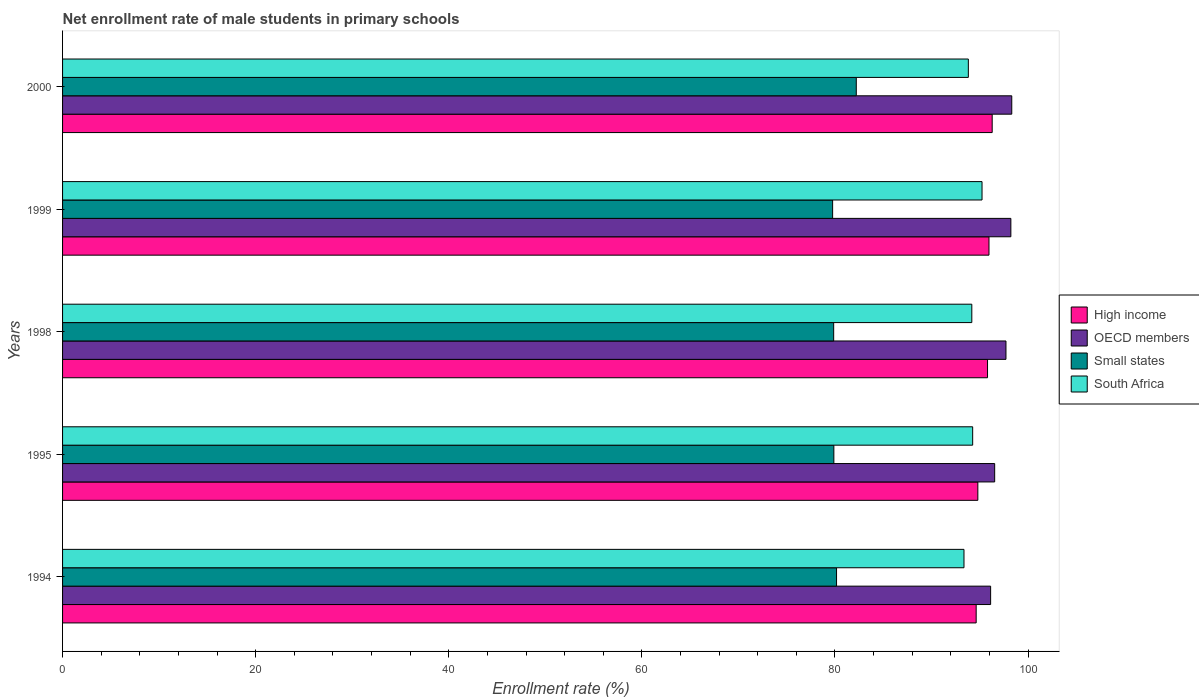How many different coloured bars are there?
Offer a very short reply. 4. How many groups of bars are there?
Your response must be concise. 5. Are the number of bars per tick equal to the number of legend labels?
Keep it short and to the point. Yes. What is the label of the 4th group of bars from the top?
Ensure brevity in your answer.  1995. In how many cases, is the number of bars for a given year not equal to the number of legend labels?
Offer a very short reply. 0. What is the net enrollment rate of male students in primary schools in Small states in 1998?
Offer a terse response. 79.86. Across all years, what is the maximum net enrollment rate of male students in primary schools in Small states?
Offer a very short reply. 82.21. Across all years, what is the minimum net enrollment rate of male students in primary schools in Small states?
Your answer should be compact. 79.75. In which year was the net enrollment rate of male students in primary schools in OECD members maximum?
Your answer should be compact. 2000. In which year was the net enrollment rate of male students in primary schools in South Africa minimum?
Provide a succinct answer. 1994. What is the total net enrollment rate of male students in primary schools in South Africa in the graph?
Offer a very short reply. 470.83. What is the difference between the net enrollment rate of male students in primary schools in South Africa in 1998 and that in 2000?
Your answer should be compact. 0.36. What is the difference between the net enrollment rate of male students in primary schools in South Africa in 1995 and the net enrollment rate of male students in primary schools in High income in 1998?
Give a very brief answer. -1.54. What is the average net enrollment rate of male students in primary schools in South Africa per year?
Offer a very short reply. 94.17. In the year 1995, what is the difference between the net enrollment rate of male students in primary schools in Small states and net enrollment rate of male students in primary schools in High income?
Your answer should be compact. -14.91. In how many years, is the net enrollment rate of male students in primary schools in Small states greater than 92 %?
Your answer should be very brief. 0. What is the ratio of the net enrollment rate of male students in primary schools in High income in 1995 to that in 2000?
Your answer should be very brief. 0.98. Is the net enrollment rate of male students in primary schools in OECD members in 1995 less than that in 1999?
Your answer should be very brief. Yes. What is the difference between the highest and the second highest net enrollment rate of male students in primary schools in Small states?
Provide a short and direct response. 2.04. What is the difference between the highest and the lowest net enrollment rate of male students in primary schools in South Africa?
Offer a very short reply. 1.87. In how many years, is the net enrollment rate of male students in primary schools in OECD members greater than the average net enrollment rate of male students in primary schools in OECD members taken over all years?
Your response must be concise. 3. Is it the case that in every year, the sum of the net enrollment rate of male students in primary schools in OECD members and net enrollment rate of male students in primary schools in South Africa is greater than the sum of net enrollment rate of male students in primary schools in High income and net enrollment rate of male students in primary schools in Small states?
Ensure brevity in your answer.  No. What does the 1st bar from the top in 2000 represents?
Your answer should be very brief. South Africa. What does the 4th bar from the bottom in 1999 represents?
Make the answer very short. South Africa. What is the difference between two consecutive major ticks on the X-axis?
Provide a short and direct response. 20. Are the values on the major ticks of X-axis written in scientific E-notation?
Give a very brief answer. No. Does the graph contain any zero values?
Your response must be concise. No. Does the graph contain grids?
Your response must be concise. No. How are the legend labels stacked?
Give a very brief answer. Vertical. What is the title of the graph?
Your response must be concise. Net enrollment rate of male students in primary schools. What is the label or title of the X-axis?
Provide a short and direct response. Enrollment rate (%). What is the Enrollment rate (%) of High income in 1994?
Offer a very short reply. 94.62. What is the Enrollment rate (%) of OECD members in 1994?
Your response must be concise. 96.12. What is the Enrollment rate (%) in Small states in 1994?
Your answer should be compact. 80.16. What is the Enrollment rate (%) of South Africa in 1994?
Offer a very short reply. 93.36. What is the Enrollment rate (%) in High income in 1995?
Your answer should be very brief. 94.8. What is the Enrollment rate (%) of OECD members in 1995?
Ensure brevity in your answer.  96.54. What is the Enrollment rate (%) in Small states in 1995?
Offer a terse response. 79.88. What is the Enrollment rate (%) of South Africa in 1995?
Make the answer very short. 94.26. What is the Enrollment rate (%) in High income in 1998?
Keep it short and to the point. 95.8. What is the Enrollment rate (%) in OECD members in 1998?
Provide a succinct answer. 97.71. What is the Enrollment rate (%) of Small states in 1998?
Your response must be concise. 79.86. What is the Enrollment rate (%) of South Africa in 1998?
Provide a short and direct response. 94.17. What is the Enrollment rate (%) of High income in 1999?
Offer a terse response. 95.95. What is the Enrollment rate (%) in OECD members in 1999?
Your answer should be very brief. 98.22. What is the Enrollment rate (%) in Small states in 1999?
Ensure brevity in your answer.  79.75. What is the Enrollment rate (%) of South Africa in 1999?
Make the answer very short. 95.23. What is the Enrollment rate (%) in High income in 2000?
Your response must be concise. 96.28. What is the Enrollment rate (%) in OECD members in 2000?
Provide a succinct answer. 98.31. What is the Enrollment rate (%) of Small states in 2000?
Your answer should be very brief. 82.21. What is the Enrollment rate (%) in South Africa in 2000?
Offer a very short reply. 93.81. Across all years, what is the maximum Enrollment rate (%) in High income?
Ensure brevity in your answer.  96.28. Across all years, what is the maximum Enrollment rate (%) in OECD members?
Keep it short and to the point. 98.31. Across all years, what is the maximum Enrollment rate (%) in Small states?
Provide a succinct answer. 82.21. Across all years, what is the maximum Enrollment rate (%) of South Africa?
Your response must be concise. 95.23. Across all years, what is the minimum Enrollment rate (%) of High income?
Provide a succinct answer. 94.62. Across all years, what is the minimum Enrollment rate (%) in OECD members?
Make the answer very short. 96.12. Across all years, what is the minimum Enrollment rate (%) in Small states?
Keep it short and to the point. 79.75. Across all years, what is the minimum Enrollment rate (%) in South Africa?
Keep it short and to the point. 93.36. What is the total Enrollment rate (%) in High income in the graph?
Your answer should be very brief. 477.45. What is the total Enrollment rate (%) of OECD members in the graph?
Provide a succinct answer. 486.89. What is the total Enrollment rate (%) in Small states in the graph?
Make the answer very short. 401.87. What is the total Enrollment rate (%) of South Africa in the graph?
Provide a short and direct response. 470.83. What is the difference between the Enrollment rate (%) in High income in 1994 and that in 1995?
Your answer should be compact. -0.17. What is the difference between the Enrollment rate (%) in OECD members in 1994 and that in 1995?
Provide a short and direct response. -0.42. What is the difference between the Enrollment rate (%) in Small states in 1994 and that in 1995?
Ensure brevity in your answer.  0.28. What is the difference between the Enrollment rate (%) of South Africa in 1994 and that in 1995?
Keep it short and to the point. -0.9. What is the difference between the Enrollment rate (%) in High income in 1994 and that in 1998?
Your answer should be very brief. -1.18. What is the difference between the Enrollment rate (%) in OECD members in 1994 and that in 1998?
Your answer should be compact. -1.59. What is the difference between the Enrollment rate (%) of Small states in 1994 and that in 1998?
Provide a succinct answer. 0.3. What is the difference between the Enrollment rate (%) of South Africa in 1994 and that in 1998?
Make the answer very short. -0.81. What is the difference between the Enrollment rate (%) in High income in 1994 and that in 1999?
Your response must be concise. -1.33. What is the difference between the Enrollment rate (%) in OECD members in 1994 and that in 1999?
Ensure brevity in your answer.  -2.1. What is the difference between the Enrollment rate (%) of Small states in 1994 and that in 1999?
Offer a very short reply. 0.41. What is the difference between the Enrollment rate (%) of South Africa in 1994 and that in 1999?
Your answer should be compact. -1.87. What is the difference between the Enrollment rate (%) in High income in 1994 and that in 2000?
Offer a very short reply. -1.66. What is the difference between the Enrollment rate (%) in OECD members in 1994 and that in 2000?
Offer a terse response. -2.19. What is the difference between the Enrollment rate (%) of Small states in 1994 and that in 2000?
Keep it short and to the point. -2.04. What is the difference between the Enrollment rate (%) of South Africa in 1994 and that in 2000?
Your response must be concise. -0.45. What is the difference between the Enrollment rate (%) of High income in 1995 and that in 1998?
Keep it short and to the point. -1. What is the difference between the Enrollment rate (%) in OECD members in 1995 and that in 1998?
Offer a very short reply. -1.17. What is the difference between the Enrollment rate (%) of Small states in 1995 and that in 1998?
Provide a short and direct response. 0.02. What is the difference between the Enrollment rate (%) in South Africa in 1995 and that in 1998?
Your answer should be very brief. 0.09. What is the difference between the Enrollment rate (%) of High income in 1995 and that in 1999?
Give a very brief answer. -1.15. What is the difference between the Enrollment rate (%) of OECD members in 1995 and that in 1999?
Your answer should be very brief. -1.68. What is the difference between the Enrollment rate (%) in Small states in 1995 and that in 1999?
Provide a short and direct response. 0.13. What is the difference between the Enrollment rate (%) in South Africa in 1995 and that in 1999?
Give a very brief answer. -0.97. What is the difference between the Enrollment rate (%) of High income in 1995 and that in 2000?
Ensure brevity in your answer.  -1.48. What is the difference between the Enrollment rate (%) in OECD members in 1995 and that in 2000?
Your response must be concise. -1.77. What is the difference between the Enrollment rate (%) in Small states in 1995 and that in 2000?
Give a very brief answer. -2.32. What is the difference between the Enrollment rate (%) of South Africa in 1995 and that in 2000?
Offer a very short reply. 0.45. What is the difference between the Enrollment rate (%) of High income in 1998 and that in 1999?
Your answer should be compact. -0.15. What is the difference between the Enrollment rate (%) in OECD members in 1998 and that in 1999?
Your response must be concise. -0.51. What is the difference between the Enrollment rate (%) in Small states in 1998 and that in 1999?
Provide a succinct answer. 0.11. What is the difference between the Enrollment rate (%) in South Africa in 1998 and that in 1999?
Keep it short and to the point. -1.06. What is the difference between the Enrollment rate (%) in High income in 1998 and that in 2000?
Give a very brief answer. -0.48. What is the difference between the Enrollment rate (%) in OECD members in 1998 and that in 2000?
Provide a short and direct response. -0.6. What is the difference between the Enrollment rate (%) in Small states in 1998 and that in 2000?
Offer a terse response. -2.34. What is the difference between the Enrollment rate (%) of South Africa in 1998 and that in 2000?
Offer a terse response. 0.36. What is the difference between the Enrollment rate (%) of High income in 1999 and that in 2000?
Your answer should be very brief. -0.33. What is the difference between the Enrollment rate (%) in OECD members in 1999 and that in 2000?
Ensure brevity in your answer.  -0.09. What is the difference between the Enrollment rate (%) of Small states in 1999 and that in 2000?
Provide a short and direct response. -2.45. What is the difference between the Enrollment rate (%) in South Africa in 1999 and that in 2000?
Keep it short and to the point. 1.42. What is the difference between the Enrollment rate (%) in High income in 1994 and the Enrollment rate (%) in OECD members in 1995?
Ensure brevity in your answer.  -1.92. What is the difference between the Enrollment rate (%) in High income in 1994 and the Enrollment rate (%) in Small states in 1995?
Your answer should be compact. 14.74. What is the difference between the Enrollment rate (%) in High income in 1994 and the Enrollment rate (%) in South Africa in 1995?
Offer a very short reply. 0.36. What is the difference between the Enrollment rate (%) of OECD members in 1994 and the Enrollment rate (%) of Small states in 1995?
Keep it short and to the point. 16.24. What is the difference between the Enrollment rate (%) of OECD members in 1994 and the Enrollment rate (%) of South Africa in 1995?
Your answer should be compact. 1.86. What is the difference between the Enrollment rate (%) in Small states in 1994 and the Enrollment rate (%) in South Africa in 1995?
Provide a short and direct response. -14.1. What is the difference between the Enrollment rate (%) of High income in 1994 and the Enrollment rate (%) of OECD members in 1998?
Provide a short and direct response. -3.09. What is the difference between the Enrollment rate (%) in High income in 1994 and the Enrollment rate (%) in Small states in 1998?
Offer a very short reply. 14.76. What is the difference between the Enrollment rate (%) of High income in 1994 and the Enrollment rate (%) of South Africa in 1998?
Offer a very short reply. 0.45. What is the difference between the Enrollment rate (%) in OECD members in 1994 and the Enrollment rate (%) in Small states in 1998?
Provide a short and direct response. 16.26. What is the difference between the Enrollment rate (%) in OECD members in 1994 and the Enrollment rate (%) in South Africa in 1998?
Offer a very short reply. 1.95. What is the difference between the Enrollment rate (%) of Small states in 1994 and the Enrollment rate (%) of South Africa in 1998?
Make the answer very short. -14.01. What is the difference between the Enrollment rate (%) of High income in 1994 and the Enrollment rate (%) of OECD members in 1999?
Give a very brief answer. -3.59. What is the difference between the Enrollment rate (%) of High income in 1994 and the Enrollment rate (%) of Small states in 1999?
Your response must be concise. 14.87. What is the difference between the Enrollment rate (%) of High income in 1994 and the Enrollment rate (%) of South Africa in 1999?
Keep it short and to the point. -0.61. What is the difference between the Enrollment rate (%) in OECD members in 1994 and the Enrollment rate (%) in Small states in 1999?
Give a very brief answer. 16.36. What is the difference between the Enrollment rate (%) of OECD members in 1994 and the Enrollment rate (%) of South Africa in 1999?
Offer a very short reply. 0.89. What is the difference between the Enrollment rate (%) in Small states in 1994 and the Enrollment rate (%) in South Africa in 1999?
Offer a terse response. -15.07. What is the difference between the Enrollment rate (%) in High income in 1994 and the Enrollment rate (%) in OECD members in 2000?
Offer a terse response. -3.69. What is the difference between the Enrollment rate (%) in High income in 1994 and the Enrollment rate (%) in Small states in 2000?
Keep it short and to the point. 12.42. What is the difference between the Enrollment rate (%) of High income in 1994 and the Enrollment rate (%) of South Africa in 2000?
Ensure brevity in your answer.  0.81. What is the difference between the Enrollment rate (%) in OECD members in 1994 and the Enrollment rate (%) in Small states in 2000?
Keep it short and to the point. 13.91. What is the difference between the Enrollment rate (%) in OECD members in 1994 and the Enrollment rate (%) in South Africa in 2000?
Provide a succinct answer. 2.31. What is the difference between the Enrollment rate (%) of Small states in 1994 and the Enrollment rate (%) of South Africa in 2000?
Your answer should be very brief. -13.65. What is the difference between the Enrollment rate (%) of High income in 1995 and the Enrollment rate (%) of OECD members in 1998?
Your response must be concise. -2.91. What is the difference between the Enrollment rate (%) in High income in 1995 and the Enrollment rate (%) in Small states in 1998?
Ensure brevity in your answer.  14.93. What is the difference between the Enrollment rate (%) in High income in 1995 and the Enrollment rate (%) in South Africa in 1998?
Make the answer very short. 0.62. What is the difference between the Enrollment rate (%) in OECD members in 1995 and the Enrollment rate (%) in Small states in 1998?
Keep it short and to the point. 16.68. What is the difference between the Enrollment rate (%) of OECD members in 1995 and the Enrollment rate (%) of South Africa in 1998?
Give a very brief answer. 2.37. What is the difference between the Enrollment rate (%) of Small states in 1995 and the Enrollment rate (%) of South Africa in 1998?
Offer a terse response. -14.29. What is the difference between the Enrollment rate (%) in High income in 1995 and the Enrollment rate (%) in OECD members in 1999?
Make the answer very short. -3.42. What is the difference between the Enrollment rate (%) in High income in 1995 and the Enrollment rate (%) in Small states in 1999?
Ensure brevity in your answer.  15.04. What is the difference between the Enrollment rate (%) in High income in 1995 and the Enrollment rate (%) in South Africa in 1999?
Your answer should be very brief. -0.43. What is the difference between the Enrollment rate (%) in OECD members in 1995 and the Enrollment rate (%) in Small states in 1999?
Provide a short and direct response. 16.78. What is the difference between the Enrollment rate (%) in OECD members in 1995 and the Enrollment rate (%) in South Africa in 1999?
Ensure brevity in your answer.  1.31. What is the difference between the Enrollment rate (%) in Small states in 1995 and the Enrollment rate (%) in South Africa in 1999?
Your response must be concise. -15.35. What is the difference between the Enrollment rate (%) in High income in 1995 and the Enrollment rate (%) in OECD members in 2000?
Make the answer very short. -3.51. What is the difference between the Enrollment rate (%) of High income in 1995 and the Enrollment rate (%) of Small states in 2000?
Your response must be concise. 12.59. What is the difference between the Enrollment rate (%) of High income in 1995 and the Enrollment rate (%) of South Africa in 2000?
Offer a very short reply. 0.98. What is the difference between the Enrollment rate (%) in OECD members in 1995 and the Enrollment rate (%) in Small states in 2000?
Your response must be concise. 14.33. What is the difference between the Enrollment rate (%) of OECD members in 1995 and the Enrollment rate (%) of South Africa in 2000?
Your response must be concise. 2.73. What is the difference between the Enrollment rate (%) of Small states in 1995 and the Enrollment rate (%) of South Africa in 2000?
Provide a succinct answer. -13.93. What is the difference between the Enrollment rate (%) in High income in 1998 and the Enrollment rate (%) in OECD members in 1999?
Offer a very short reply. -2.42. What is the difference between the Enrollment rate (%) of High income in 1998 and the Enrollment rate (%) of Small states in 1999?
Make the answer very short. 16.04. What is the difference between the Enrollment rate (%) of High income in 1998 and the Enrollment rate (%) of South Africa in 1999?
Offer a terse response. 0.57. What is the difference between the Enrollment rate (%) in OECD members in 1998 and the Enrollment rate (%) in Small states in 1999?
Provide a short and direct response. 17.95. What is the difference between the Enrollment rate (%) of OECD members in 1998 and the Enrollment rate (%) of South Africa in 1999?
Your answer should be very brief. 2.48. What is the difference between the Enrollment rate (%) in Small states in 1998 and the Enrollment rate (%) in South Africa in 1999?
Make the answer very short. -15.37. What is the difference between the Enrollment rate (%) in High income in 1998 and the Enrollment rate (%) in OECD members in 2000?
Give a very brief answer. -2.51. What is the difference between the Enrollment rate (%) of High income in 1998 and the Enrollment rate (%) of Small states in 2000?
Offer a terse response. 13.59. What is the difference between the Enrollment rate (%) of High income in 1998 and the Enrollment rate (%) of South Africa in 2000?
Ensure brevity in your answer.  1.99. What is the difference between the Enrollment rate (%) of OECD members in 1998 and the Enrollment rate (%) of Small states in 2000?
Offer a terse response. 15.5. What is the difference between the Enrollment rate (%) in OECD members in 1998 and the Enrollment rate (%) in South Africa in 2000?
Ensure brevity in your answer.  3.9. What is the difference between the Enrollment rate (%) of Small states in 1998 and the Enrollment rate (%) of South Africa in 2000?
Provide a succinct answer. -13.95. What is the difference between the Enrollment rate (%) of High income in 1999 and the Enrollment rate (%) of OECD members in 2000?
Ensure brevity in your answer.  -2.36. What is the difference between the Enrollment rate (%) in High income in 1999 and the Enrollment rate (%) in Small states in 2000?
Your answer should be compact. 13.74. What is the difference between the Enrollment rate (%) of High income in 1999 and the Enrollment rate (%) of South Africa in 2000?
Ensure brevity in your answer.  2.14. What is the difference between the Enrollment rate (%) of OECD members in 1999 and the Enrollment rate (%) of Small states in 2000?
Offer a terse response. 16.01. What is the difference between the Enrollment rate (%) in OECD members in 1999 and the Enrollment rate (%) in South Africa in 2000?
Provide a short and direct response. 4.4. What is the difference between the Enrollment rate (%) in Small states in 1999 and the Enrollment rate (%) in South Africa in 2000?
Your answer should be compact. -14.06. What is the average Enrollment rate (%) of High income per year?
Offer a terse response. 95.49. What is the average Enrollment rate (%) of OECD members per year?
Give a very brief answer. 97.38. What is the average Enrollment rate (%) in Small states per year?
Your answer should be very brief. 80.37. What is the average Enrollment rate (%) of South Africa per year?
Ensure brevity in your answer.  94.17. In the year 1994, what is the difference between the Enrollment rate (%) of High income and Enrollment rate (%) of OECD members?
Your response must be concise. -1.5. In the year 1994, what is the difference between the Enrollment rate (%) in High income and Enrollment rate (%) in Small states?
Provide a succinct answer. 14.46. In the year 1994, what is the difference between the Enrollment rate (%) in High income and Enrollment rate (%) in South Africa?
Keep it short and to the point. 1.26. In the year 1994, what is the difference between the Enrollment rate (%) of OECD members and Enrollment rate (%) of Small states?
Offer a terse response. 15.96. In the year 1994, what is the difference between the Enrollment rate (%) of OECD members and Enrollment rate (%) of South Africa?
Offer a very short reply. 2.76. In the year 1994, what is the difference between the Enrollment rate (%) in Small states and Enrollment rate (%) in South Africa?
Give a very brief answer. -13.2. In the year 1995, what is the difference between the Enrollment rate (%) of High income and Enrollment rate (%) of OECD members?
Ensure brevity in your answer.  -1.74. In the year 1995, what is the difference between the Enrollment rate (%) of High income and Enrollment rate (%) of Small states?
Provide a short and direct response. 14.91. In the year 1995, what is the difference between the Enrollment rate (%) in High income and Enrollment rate (%) in South Africa?
Your answer should be compact. 0.54. In the year 1995, what is the difference between the Enrollment rate (%) of OECD members and Enrollment rate (%) of Small states?
Your response must be concise. 16.66. In the year 1995, what is the difference between the Enrollment rate (%) of OECD members and Enrollment rate (%) of South Africa?
Offer a very short reply. 2.28. In the year 1995, what is the difference between the Enrollment rate (%) in Small states and Enrollment rate (%) in South Africa?
Provide a short and direct response. -14.38. In the year 1998, what is the difference between the Enrollment rate (%) in High income and Enrollment rate (%) in OECD members?
Your answer should be compact. -1.91. In the year 1998, what is the difference between the Enrollment rate (%) in High income and Enrollment rate (%) in Small states?
Offer a very short reply. 15.94. In the year 1998, what is the difference between the Enrollment rate (%) in High income and Enrollment rate (%) in South Africa?
Offer a terse response. 1.63. In the year 1998, what is the difference between the Enrollment rate (%) in OECD members and Enrollment rate (%) in Small states?
Offer a terse response. 17.85. In the year 1998, what is the difference between the Enrollment rate (%) of OECD members and Enrollment rate (%) of South Africa?
Your answer should be very brief. 3.54. In the year 1998, what is the difference between the Enrollment rate (%) in Small states and Enrollment rate (%) in South Africa?
Your response must be concise. -14.31. In the year 1999, what is the difference between the Enrollment rate (%) of High income and Enrollment rate (%) of OECD members?
Give a very brief answer. -2.27. In the year 1999, what is the difference between the Enrollment rate (%) in High income and Enrollment rate (%) in Small states?
Offer a terse response. 16.19. In the year 1999, what is the difference between the Enrollment rate (%) of High income and Enrollment rate (%) of South Africa?
Your answer should be very brief. 0.72. In the year 1999, what is the difference between the Enrollment rate (%) of OECD members and Enrollment rate (%) of Small states?
Provide a short and direct response. 18.46. In the year 1999, what is the difference between the Enrollment rate (%) of OECD members and Enrollment rate (%) of South Africa?
Keep it short and to the point. 2.99. In the year 1999, what is the difference between the Enrollment rate (%) of Small states and Enrollment rate (%) of South Africa?
Provide a short and direct response. -15.47. In the year 2000, what is the difference between the Enrollment rate (%) of High income and Enrollment rate (%) of OECD members?
Provide a short and direct response. -2.03. In the year 2000, what is the difference between the Enrollment rate (%) of High income and Enrollment rate (%) of Small states?
Provide a short and direct response. 14.08. In the year 2000, what is the difference between the Enrollment rate (%) of High income and Enrollment rate (%) of South Africa?
Give a very brief answer. 2.47. In the year 2000, what is the difference between the Enrollment rate (%) of OECD members and Enrollment rate (%) of Small states?
Make the answer very short. 16.1. In the year 2000, what is the difference between the Enrollment rate (%) of OECD members and Enrollment rate (%) of South Africa?
Provide a succinct answer. 4.5. In the year 2000, what is the difference between the Enrollment rate (%) of Small states and Enrollment rate (%) of South Africa?
Offer a terse response. -11.61. What is the ratio of the Enrollment rate (%) of Small states in 1994 to that in 1995?
Provide a short and direct response. 1. What is the ratio of the Enrollment rate (%) of South Africa in 1994 to that in 1995?
Your response must be concise. 0.99. What is the ratio of the Enrollment rate (%) in OECD members in 1994 to that in 1998?
Offer a terse response. 0.98. What is the ratio of the Enrollment rate (%) in Small states in 1994 to that in 1998?
Make the answer very short. 1. What is the ratio of the Enrollment rate (%) of High income in 1994 to that in 1999?
Make the answer very short. 0.99. What is the ratio of the Enrollment rate (%) in OECD members in 1994 to that in 1999?
Offer a terse response. 0.98. What is the ratio of the Enrollment rate (%) in South Africa in 1994 to that in 1999?
Provide a short and direct response. 0.98. What is the ratio of the Enrollment rate (%) in High income in 1994 to that in 2000?
Keep it short and to the point. 0.98. What is the ratio of the Enrollment rate (%) of OECD members in 1994 to that in 2000?
Ensure brevity in your answer.  0.98. What is the ratio of the Enrollment rate (%) of Small states in 1994 to that in 2000?
Give a very brief answer. 0.98. What is the ratio of the Enrollment rate (%) in South Africa in 1994 to that in 2000?
Ensure brevity in your answer.  1. What is the ratio of the Enrollment rate (%) of High income in 1995 to that in 1998?
Your answer should be very brief. 0.99. What is the ratio of the Enrollment rate (%) of OECD members in 1995 to that in 1998?
Give a very brief answer. 0.99. What is the ratio of the Enrollment rate (%) of High income in 1995 to that in 1999?
Make the answer very short. 0.99. What is the ratio of the Enrollment rate (%) of OECD members in 1995 to that in 1999?
Your response must be concise. 0.98. What is the ratio of the Enrollment rate (%) in Small states in 1995 to that in 1999?
Offer a terse response. 1. What is the ratio of the Enrollment rate (%) in South Africa in 1995 to that in 1999?
Provide a succinct answer. 0.99. What is the ratio of the Enrollment rate (%) of High income in 1995 to that in 2000?
Provide a short and direct response. 0.98. What is the ratio of the Enrollment rate (%) of Small states in 1995 to that in 2000?
Your response must be concise. 0.97. What is the ratio of the Enrollment rate (%) of South Africa in 1995 to that in 2000?
Provide a short and direct response. 1. What is the ratio of the Enrollment rate (%) in High income in 1998 to that in 1999?
Your answer should be very brief. 1. What is the ratio of the Enrollment rate (%) in Small states in 1998 to that in 1999?
Offer a terse response. 1. What is the ratio of the Enrollment rate (%) of South Africa in 1998 to that in 1999?
Offer a terse response. 0.99. What is the ratio of the Enrollment rate (%) in OECD members in 1998 to that in 2000?
Offer a very short reply. 0.99. What is the ratio of the Enrollment rate (%) of Small states in 1998 to that in 2000?
Make the answer very short. 0.97. What is the ratio of the Enrollment rate (%) in OECD members in 1999 to that in 2000?
Offer a very short reply. 1. What is the ratio of the Enrollment rate (%) in Small states in 1999 to that in 2000?
Your answer should be compact. 0.97. What is the ratio of the Enrollment rate (%) of South Africa in 1999 to that in 2000?
Make the answer very short. 1.02. What is the difference between the highest and the second highest Enrollment rate (%) of High income?
Your answer should be very brief. 0.33. What is the difference between the highest and the second highest Enrollment rate (%) in OECD members?
Give a very brief answer. 0.09. What is the difference between the highest and the second highest Enrollment rate (%) in Small states?
Keep it short and to the point. 2.04. What is the difference between the highest and the second highest Enrollment rate (%) of South Africa?
Your answer should be compact. 0.97. What is the difference between the highest and the lowest Enrollment rate (%) in High income?
Provide a succinct answer. 1.66. What is the difference between the highest and the lowest Enrollment rate (%) in OECD members?
Keep it short and to the point. 2.19. What is the difference between the highest and the lowest Enrollment rate (%) in Small states?
Offer a very short reply. 2.45. What is the difference between the highest and the lowest Enrollment rate (%) in South Africa?
Offer a terse response. 1.87. 